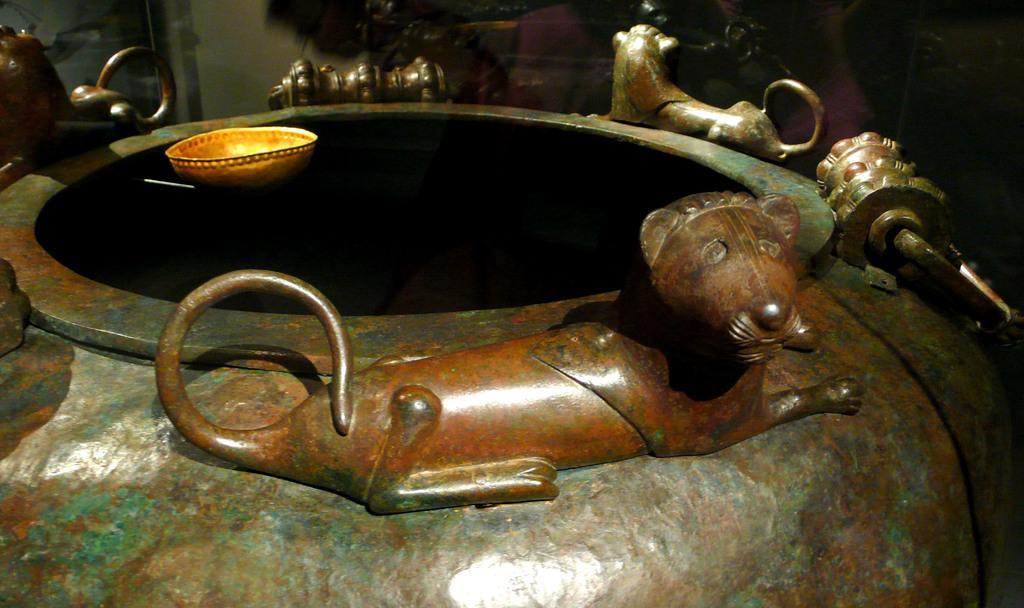Could you give a brief overview of what you see in this image? In the image we can see there is a vessel on which there are lion structure on it and there is a bowl. 